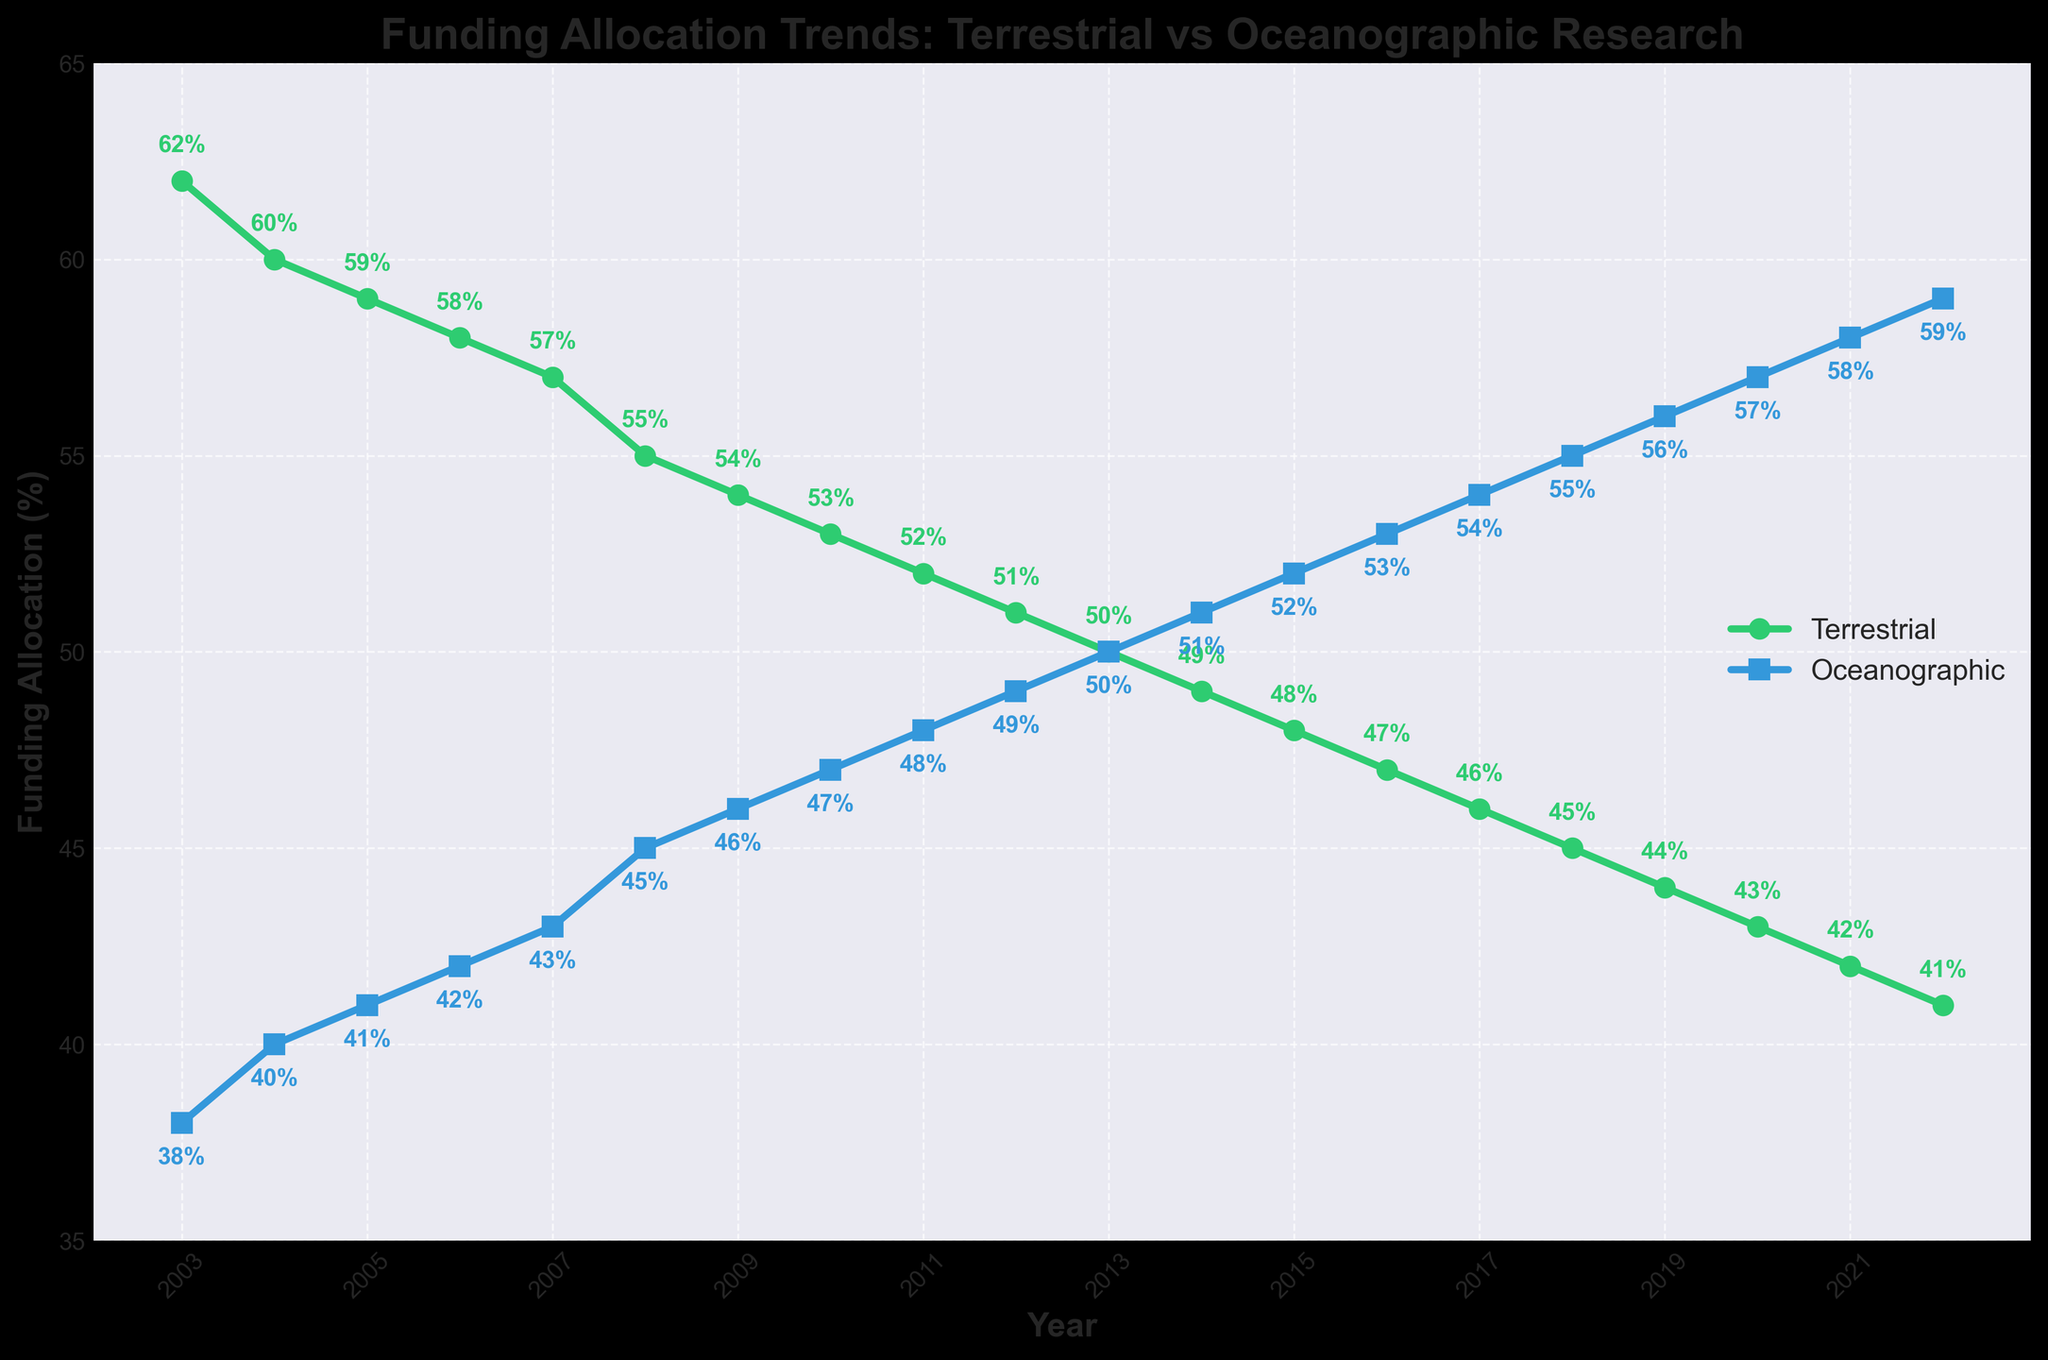What year did terrestrial research funding and oceanographic research funding equalize? The funding for terrestrial and oceanographic research was equalized when both reached 50%. By looking at the figure, it's clear this crossover occurred in the year 2013.
Answer: 2013 By how much did oceanographic research funding increase from 2003 to 2022? To find the increase in oceanographic research funding, subtract the initial percentage in 2003 from the final percentage in 2022. This is calculated as 59% (2022) - 38% (2003) = 21%.
Answer: 21% For how many consecutive years did terrestrial research funding decrease? By examining the trend line for terrestrial research funding, it is evident that it decreases each year from 2003 to 2022. Counting these years results in 20 consecutive years.
Answer: 20 years What is the funding difference between terrestrial research and oceanographic research in 2010? In 2010, terrestrial research funding was 53% and oceanographic research funding was 47%. The difference is computed as 53% - 47% = 6%.
Answer: 6% Which research type received more funding in 2018, and by how much? In 2018, terrestrial research funding was at 45%, and oceanographic research funding was at 55%. Oceanographic research received more funding by 55% - 45% = 10%.
Answer: Oceanographic, 10% What is the average terrestrial research funding over the entire period? To get the average, sum up all the terrestrial research funding percentages from 2003 to 2022 and divide by the number of years. The sum is (62+60+59+58+57+55+54+53+52+51+50+49+48+47+46+45+44+43+42+41)/20 = 51.75%.
Answer: 51.75% In what year did oceanographic research funding reach 50% for the first time? Referring to the figure, oceanographic research funding reached 50% in the year 2013.
Answer: 2013 By how much did terrestrial research funding decrease between 2007 and 2012? To find the decrease, subtract the percentage in 2012 from that in 2007. This is 57% (2007) - 51% (2012) = 6%.
Answer: 6% What is the trend in terrestrial research funding over the last 20 years, increasing or decreasing? By observing the line for terrestrial research funding over the entire period, it shows a consistent decrease each year.
Answer: Decreasing 